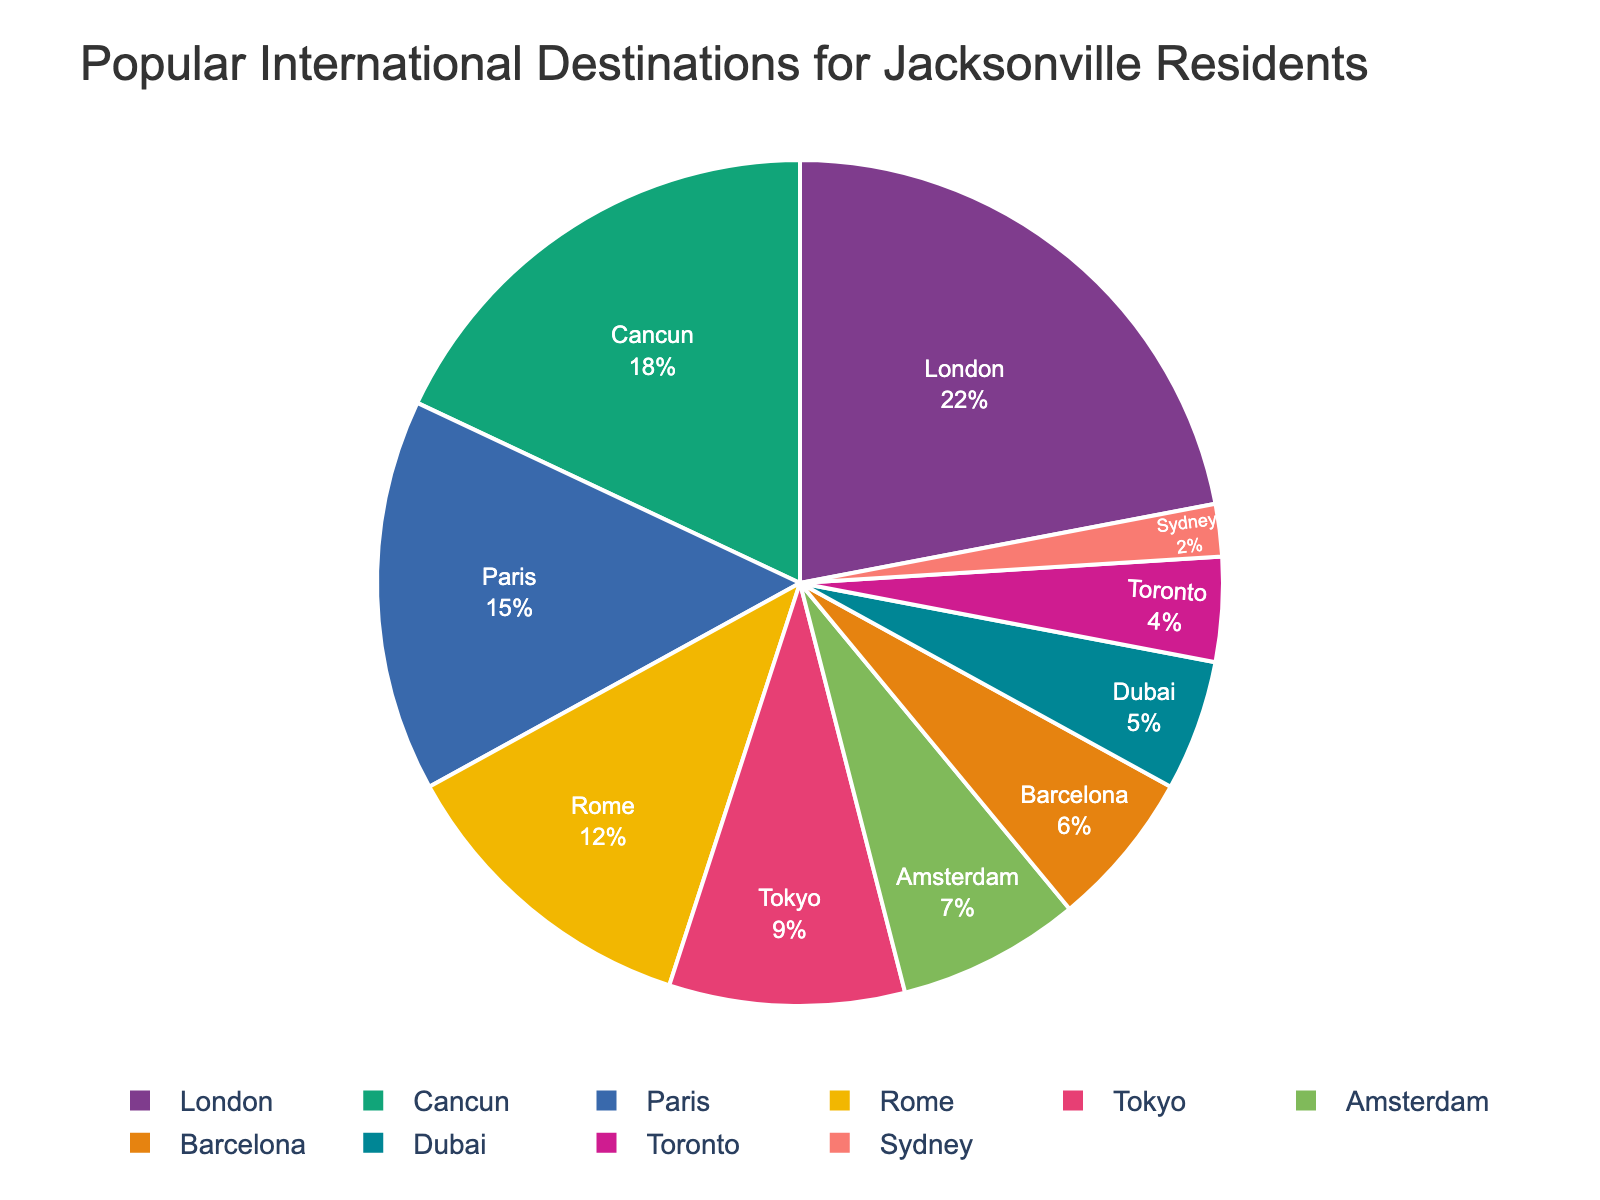What's the most popular international destination for Jacksonville residents? The largest segment on the pie chart represents the most popular destination. By looking at the segments, London has the highest percentage at 22%.
Answer: London Which destination has a segment that is smaller than Tokyo's but larger than Amsterdam's? Tokyo's segment is 9%, and Amsterdam's segment is 7%. Checking the segments, Barcelona has 6%, which is less than Amsterdam. Dubai has 5%, which is also less than Amsterdam. Therefore, Toronto with 4% fits the criterion.
Answer: Toronto How much more popular is Rome compared to Dubai? The segment for Rome is 12%, and the segment for Dubai is 5%. To find the difference, subtract the smaller percentage from the larger one: 12% - 5% = 7%.
Answer: 7% What is the total percentage for destinations that are less popular than Tokyo? Tokyo has a 9% share. The less popular destinations are Amsterdam (7%), Barcelona (6%), Dubai (5%), Toronto (4%), and Sydney (2%). Adding these gives us 7% + 6% + 5% +4% + 2% = 24%.
Answer: 24% Rank the top three destinations in descending order based on their percentage share. The top three destinations according to the pie chart are London (22%), Cancun (18%), and Paris (15%). Listing them in descending order: London, Cancun, Paris.
Answer: London, Cancun, Paris What is the combined percentage of the destinations represented in blue and green segments? To answer this, identify the segments colored in blue and green on the pie chart. Assuming London is represented in blue (22%) and Cancun in green (18%), their combined percentage is 22% + 18% = 40%.
Answer: 40% Which destination is the least popular among Jacksonville residents? The smallest segment on the pie chart represents the least popular destination. According to the chart, the segment for Sydney is the smallest, with a share of only 2%.
Answer: Sydney 